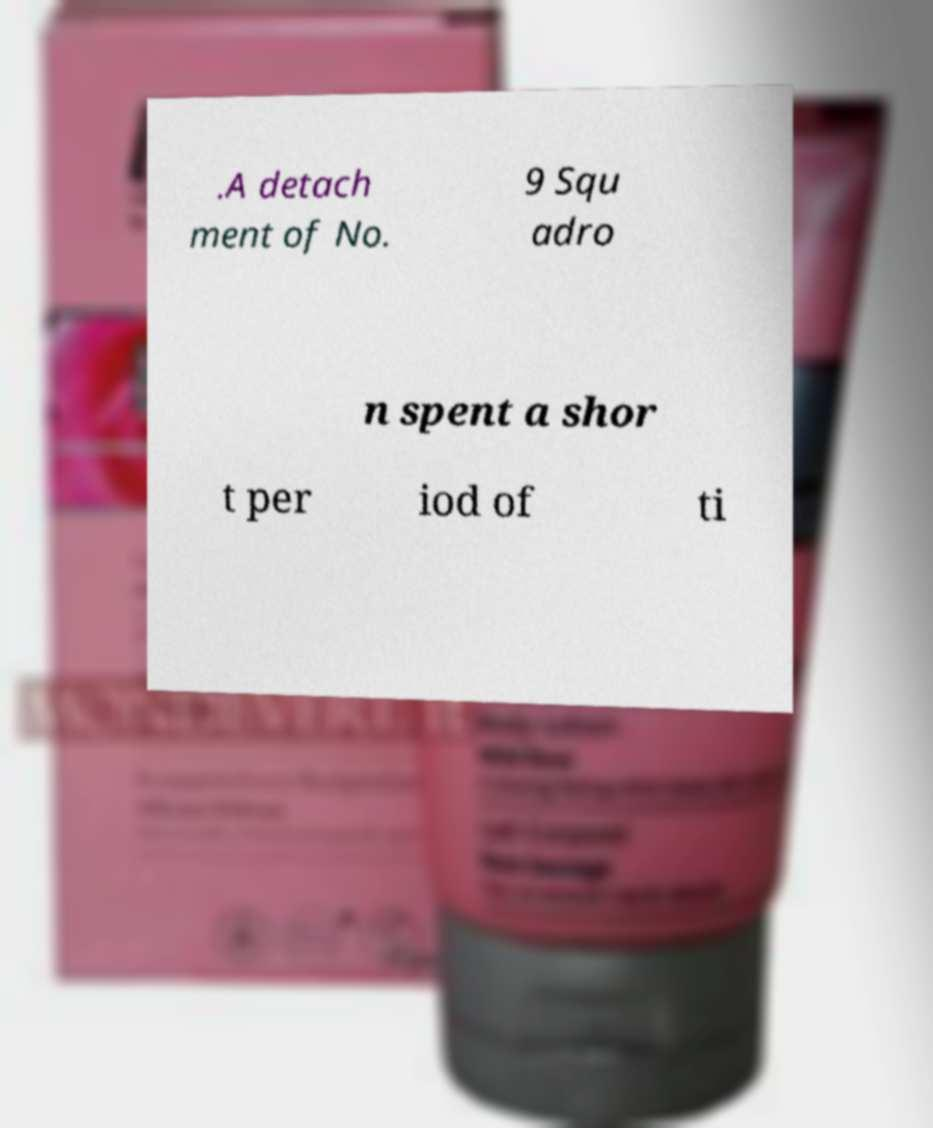Can you read and provide the text displayed in the image?This photo seems to have some interesting text. Can you extract and type it out for me? .A detach ment of No. 9 Squ adro n spent a shor t per iod of ti 